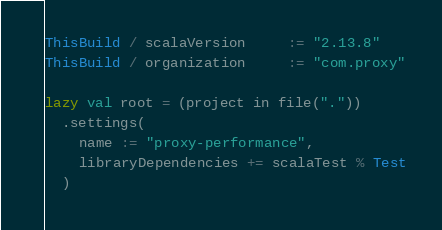Convert code to text. <code><loc_0><loc_0><loc_500><loc_500><_Scala_>
ThisBuild / scalaVersion     := "2.13.8"
ThisBuild / organization     := "com.proxy"

lazy val root = (project in file("."))
  .settings(
    name := "proxy-performance",
    libraryDependencies += scalaTest % Test
  )
</code> 